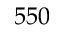Convert formula to latex. <formula><loc_0><loc_0><loc_500><loc_500>5 5 0</formula> 